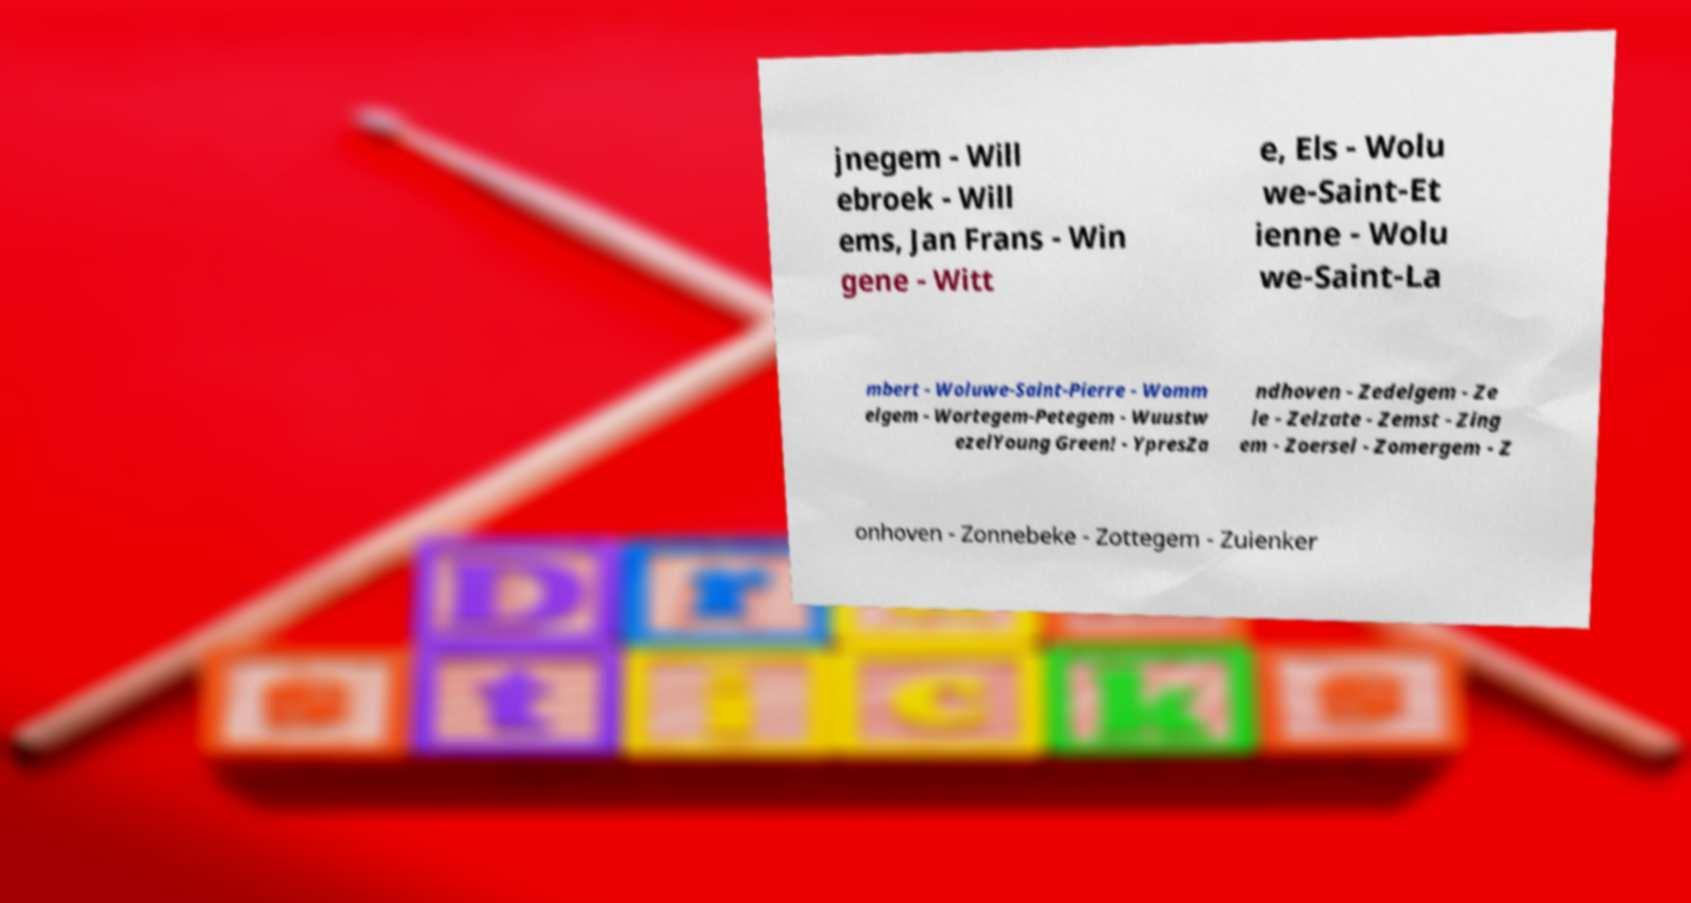Please read and relay the text visible in this image. What does it say? jnegem - Will ebroek - Will ems, Jan Frans - Win gene - Witt e, Els - Wolu we-Saint-Et ienne - Wolu we-Saint-La mbert - Woluwe-Saint-Pierre - Womm elgem - Wortegem-Petegem - Wuustw ezelYoung Green! - YpresZa ndhoven - Zedelgem - Ze le - Zelzate - Zemst - Zing em - Zoersel - Zomergem - Z onhoven - Zonnebeke - Zottegem - Zuienker 